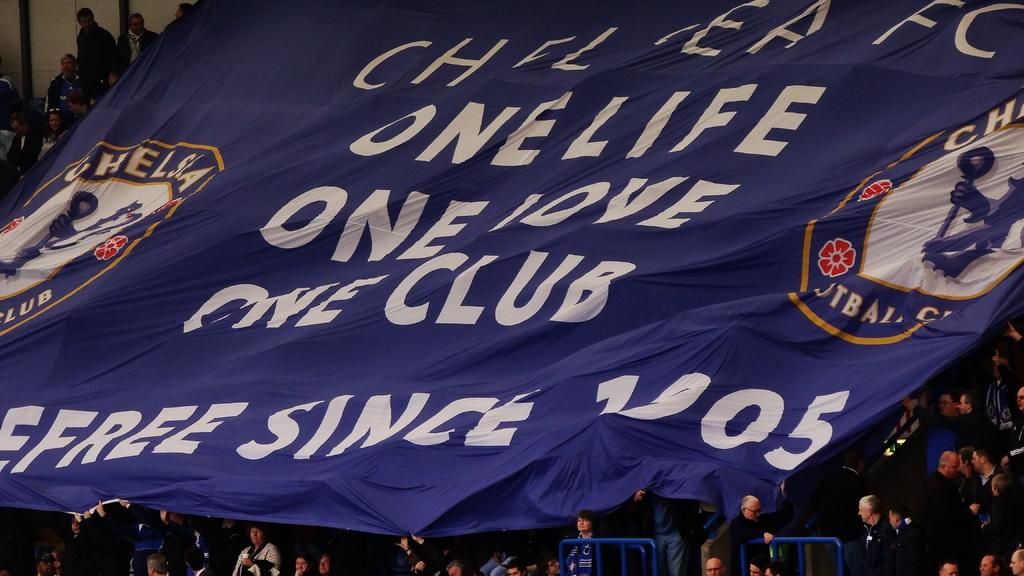What is featured on the banner in the image? The banner in the image has text and emblems. Can you describe the people in the background of the image? There are people in the background of the image, but their specific actions or appearances cannot be determined from the provided facts. What type of structure is present at the bottom of the image? Metal rods are present at the bottom of the image. What can be seen on the left side of the image? There is a wall visible in the left top part of the image. What type of board is being used by the people in the image? There is no board visible in the image, and the specific actions or activities of the people cannot be determined from the provided facts. Can you tell me how many forks are present in the image? There are no forks present in the image. 